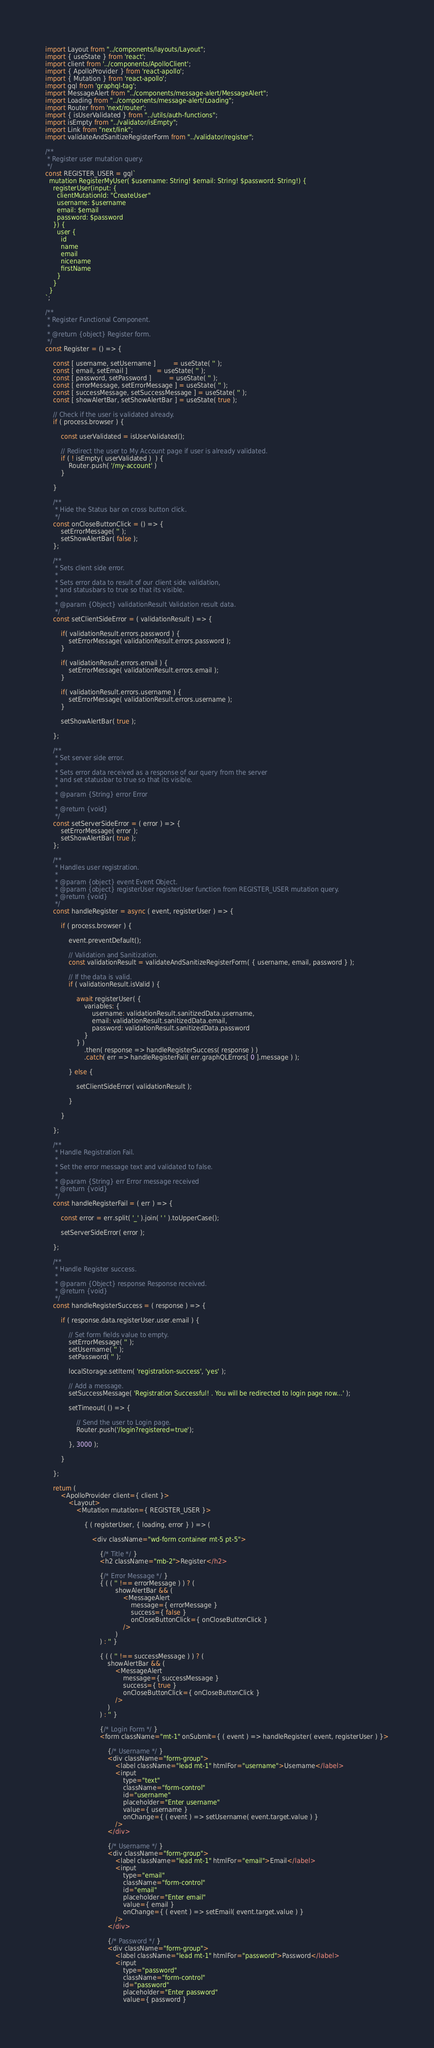<code> <loc_0><loc_0><loc_500><loc_500><_JavaScript_>import Layout from "../components/layouts/Layout";
import { useState } from 'react';
import client from '../components/ApolloClient';
import { ApolloProvider } from 'react-apollo';
import { Mutation } from 'react-apollo';
import gql from 'graphql-tag';
import MessageAlert from "../components/message-alert/MessageAlert";
import Loading from "../components/message-alert/Loading";
import Router from 'next/router';
import { isUserValidated } from "../utils/auth-functions";
import isEmpty from "../validator/isEmpty";
import Link from "next/link";
import validateAndSanitizeRegisterForm from "../validator/register";

/**
 * Register user mutation query.
 */
const REGISTER_USER = gql`
  mutation RegisterMyUser( $username: String! $email: String! $password: String!) {
    registerUser(input: {
      clientMutationId: "CreateUser"
      username: $username
      email: $email
      password: $password
    }) {
      user {
        id
        name
        email
		nicename
		firstName
      }
    }
  }
`;

/**
 * Register Functional Component.
 *
 * @return {object} Register form.
 */
const Register = () => {

	const [ username, setUsername ]         = useState( '' );
	const [ email, setEmail ]               = useState( '' );
	const [ password, setPassword ]         = useState( '' );
	const [ errorMessage, setErrorMessage ] = useState( '' );
	const [ successMessage, setSuccessMessage ] = useState( '' );
	const [ showAlertBar, setShowAlertBar ] = useState( true );

	// Check if the user is validated already.
	if ( process.browser ) {

		const userValidated = isUserValidated();

		// Redirect the user to My Account page if user is already validated.
		if ( ! isEmpty( userValidated )  ) {
			Router.push( '/my-account' )
		}

	}

	/**
	 * Hide the Status bar on cross button click.
	 */
	const onCloseButtonClick = () => {
		setErrorMessage( '' );
		setShowAlertBar( false );
	};

	/**
	 * Sets client side error.
	 *
	 * Sets error data to result of our client side validation,
	 * and statusbars to true so that its visible.
	 *
	 * @param {Object} validationResult Validation result data.
	 */
	const setClientSideError = ( validationResult ) => {

		if( validationResult.errors.password ) {
			setErrorMessage( validationResult.errors.password );
		}

		if( validationResult.errors.email ) {
			setErrorMessage( validationResult.errors.email );
		}

		if( validationResult.errors.username ) {
			setErrorMessage( validationResult.errors.username );
		}

		setShowAlertBar( true );

	};

	/**
	 * Set server side error.
	 *
	 * Sets error data received as a response of our query from the server
	 * and set statusbar to true so that its visible.
	 *
	 * @param {String} error Error
	 *
	 * @return {void}
	 */
	const setServerSideError = ( error ) => {
		setErrorMessage( error );
		setShowAlertBar( true );
	};

	/**
	 * Handles user registration.
	 *
	 * @param {object} event Event Object.
	 * @param {object} registerUser registerUser function from REGISTER_USER mutation query.
	 * @return {void}
	 */
	const handleRegister = async ( event, registerUser ) => {

		if ( process.browser ) {

			event.preventDefault();

			// Validation and Sanitization.
			const validationResult = validateAndSanitizeRegisterForm( { username, email, password } );

			// If the data is valid.
			if ( validationResult.isValid ) {

				await registerUser( {
					variables: {
						username: validationResult.sanitizedData.username,
						email: validationResult.sanitizedData.email,
						password: validationResult.sanitizedData.password
					}
				} )
					.then( response => handleRegisterSuccess( response ) )
					.catch( err => handleRegisterFail( err.graphQLErrors[ 0 ].message ) );

			} else {

				setClientSideError( validationResult );

			}

		}

	};

	/**
	 * Handle Registration Fail.
	 *
	 * Set the error message text and validated to false.
	 *
	 * @param {String} err Error message received
	 * @return {void}
	 */
	const handleRegisterFail = ( err ) => {

		const error = err.split( '_' ).join( ' ' ).toUpperCase();

		setServerSideError( error );

	};

	/**
	 * Handle Register success.
	 *
	 * @param {Object} response Response received.
	 * @return {void}
	 */
	const handleRegisterSuccess = ( response ) => {

		if ( response.data.registerUser.user.email ) {

			// Set form fields value to empty.
			setErrorMessage( '' );
			setUsername( '' );
			setPassword( '' );

			localStorage.setItem( 'registration-success', 'yes' );

			// Add a message.
			setSuccessMessage( 'Registration Successful! . You will be redirected to login page now...' );

			setTimeout( () => {

				// Send the user to Login page.
				Router.push('/login?registered=true');

			}, 3000 );

		}

	};

	return (
		<ApolloProvider client={ client }>
			<Layout>
				<Mutation mutation={ REGISTER_USER }>

					{ ( registerUser, { loading, error } ) => (

						<div className="wd-form container mt-5 pt-5">

							{/* Title */ }
							<h2 className="mb-2">Register</h2>

							{/* Error Message */ }
							{ ( ( '' !== errorMessage ) ) ? (
									showAlertBar && (
										<MessageAlert
											message={ errorMessage }
											success={ false }
											onCloseButtonClick={ onCloseButtonClick }
										/>
									)
							) : '' }

							{ ( ( '' !== successMessage ) ) ? (
								showAlertBar && (
									<MessageAlert
										message={ successMessage }
										success={ true }
										onCloseButtonClick={ onCloseButtonClick }
									/>
								)
							) : '' }

							{/* Login Form */ }
							<form className="mt-1" onSubmit={ ( event ) => handleRegister( event, registerUser ) }>

								{/* Username */ }
								<div className="form-group">
									<label className="lead mt-1" htmlFor="username">Username</label>
									<input
										type="text"
										className="form-control"
										id="username"
										placeholder="Enter username"
										value={ username }
										onChange={ ( event ) => setUsername( event.target.value ) }
									/>
								</div>

								{/* Username */ }
								<div className="form-group">
									<label className="lead mt-1" htmlFor="email">Email</label>
									<input
										type="email"
										className="form-control"
										id="email"
										placeholder="Enter email"
										value={ email }
										onChange={ ( event ) => setEmail( event.target.value ) }
									/>
								</div>

								{/* Password */ }
								<div className="form-group">
									<label className="lead mt-1" htmlFor="password">Password</label>
									<input
										type="password"
										className="form-control"
										id="password"
										placeholder="Enter password"
										value={ password }</code> 